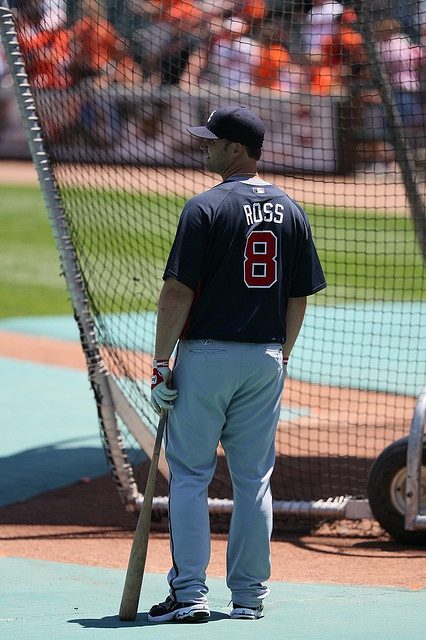Describe the objects in this image and their specific colors. I can see people in darkblue, black, blue, and gray tones, people in darkblue, maroon, brown, and black tones, baseball bat in darkblue, black, gray, and darkgray tones, people in darkblue, darkgray, gray, and brown tones, and people in darkblue, gray, black, and darkgray tones in this image. 